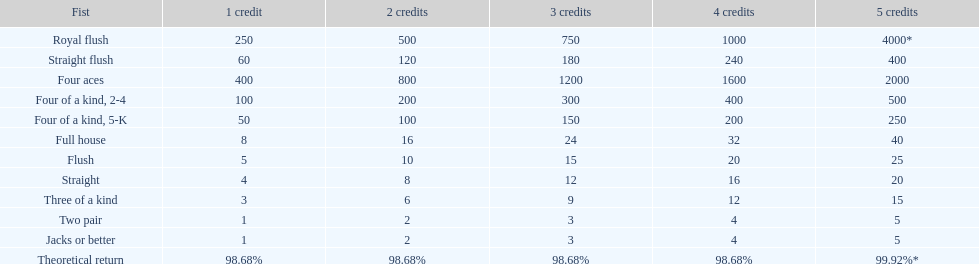Upon securing a full house win with four credits, what amount is paid out? 32. 